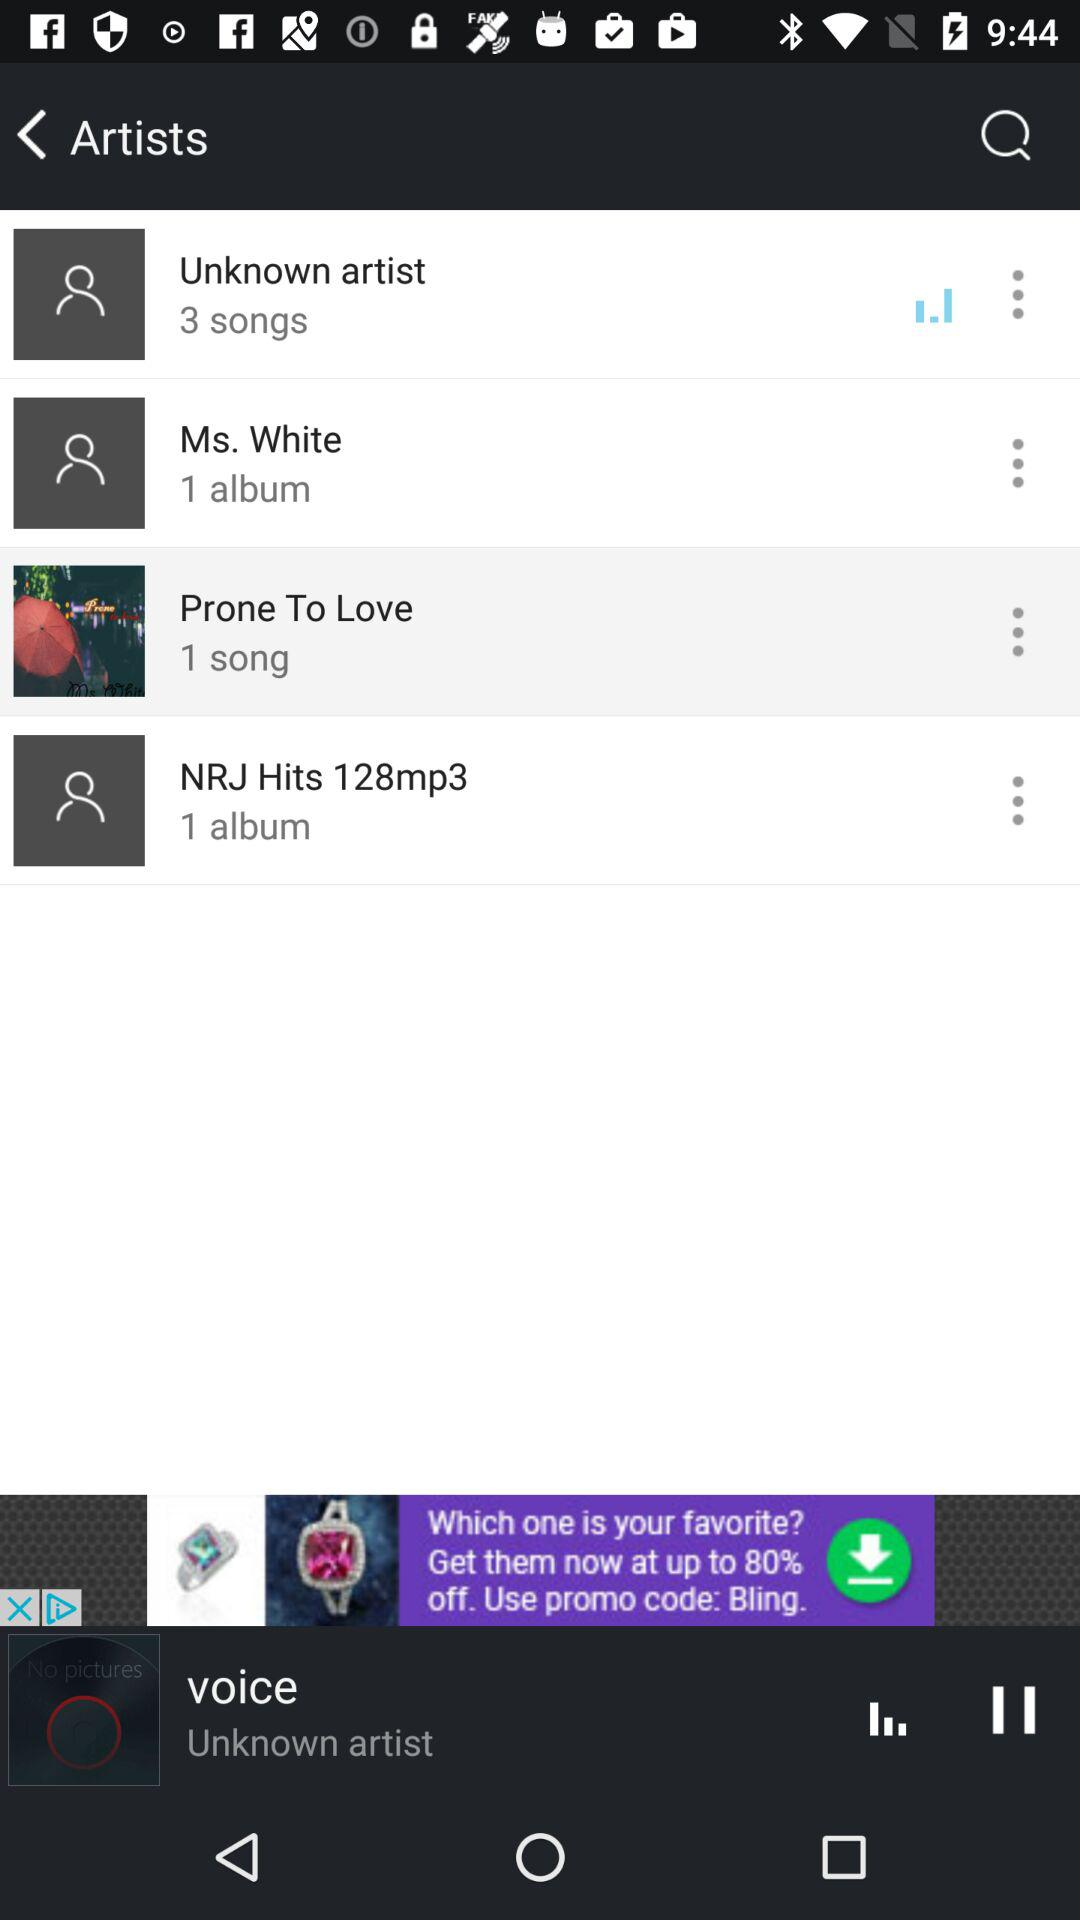Which album is playing currently?
When the provided information is insufficient, respond with <no answer>. <no answer> 